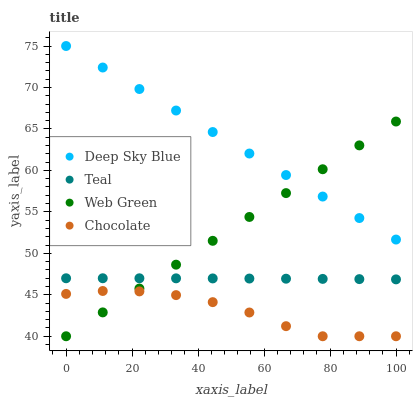Does Chocolate have the minimum area under the curve?
Answer yes or no. Yes. Does Deep Sky Blue have the maximum area under the curve?
Answer yes or no. Yes. Does Teal have the minimum area under the curve?
Answer yes or no. No. Does Teal have the maximum area under the curve?
Answer yes or no. No. Is Web Green the smoothest?
Answer yes or no. Yes. Is Chocolate the roughest?
Answer yes or no. Yes. Is Teal the smoothest?
Answer yes or no. No. Is Teal the roughest?
Answer yes or no. No. Does Web Green have the lowest value?
Answer yes or no. Yes. Does Teal have the lowest value?
Answer yes or no. No. Does Deep Sky Blue have the highest value?
Answer yes or no. Yes. Does Teal have the highest value?
Answer yes or no. No. Is Chocolate less than Deep Sky Blue?
Answer yes or no. Yes. Is Deep Sky Blue greater than Chocolate?
Answer yes or no. Yes. Does Web Green intersect Deep Sky Blue?
Answer yes or no. Yes. Is Web Green less than Deep Sky Blue?
Answer yes or no. No. Is Web Green greater than Deep Sky Blue?
Answer yes or no. No. Does Chocolate intersect Deep Sky Blue?
Answer yes or no. No. 